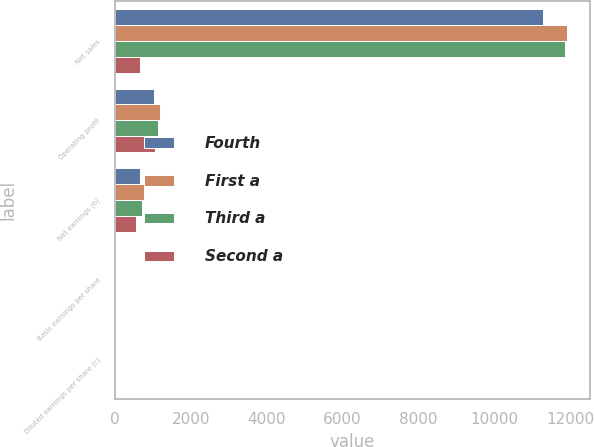Convert chart. <chart><loc_0><loc_0><loc_500><loc_500><stacked_bar_chart><ecel><fcel>Net sales<fcel>Operating profit<fcel>Net earnings (b)<fcel>Basic earnings per share<fcel>Diluted earnings per share (c)<nl><fcel>Fourth<fcel>11293<fcel>1044<fcel>668<fcel>2.06<fcel>2.03<nl><fcel>First a<fcel>11921<fcel>1192<fcel>781<fcel>2.41<fcel>2.38<nl><fcel>Third a<fcel>11869<fcel>1137<fcel>727<fcel>2.25<fcel>2.21<nl><fcel>Second a<fcel>668<fcel>1061<fcel>569<fcel>1.76<fcel>1.73<nl></chart> 